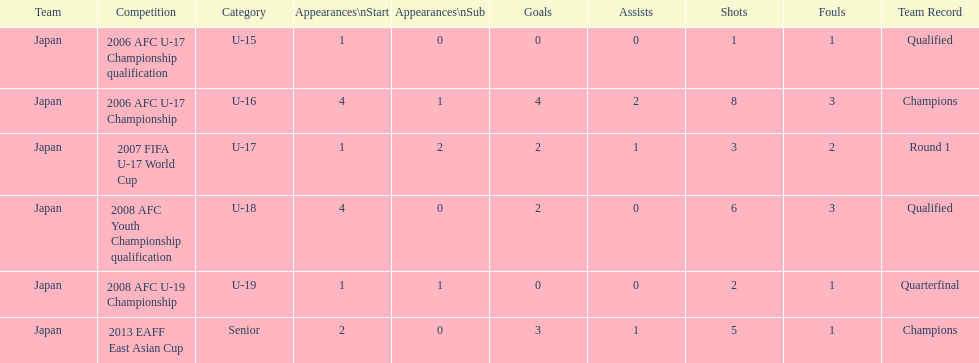What competition did japan compete in 2013? 2013 EAFF East Asian Cup. 